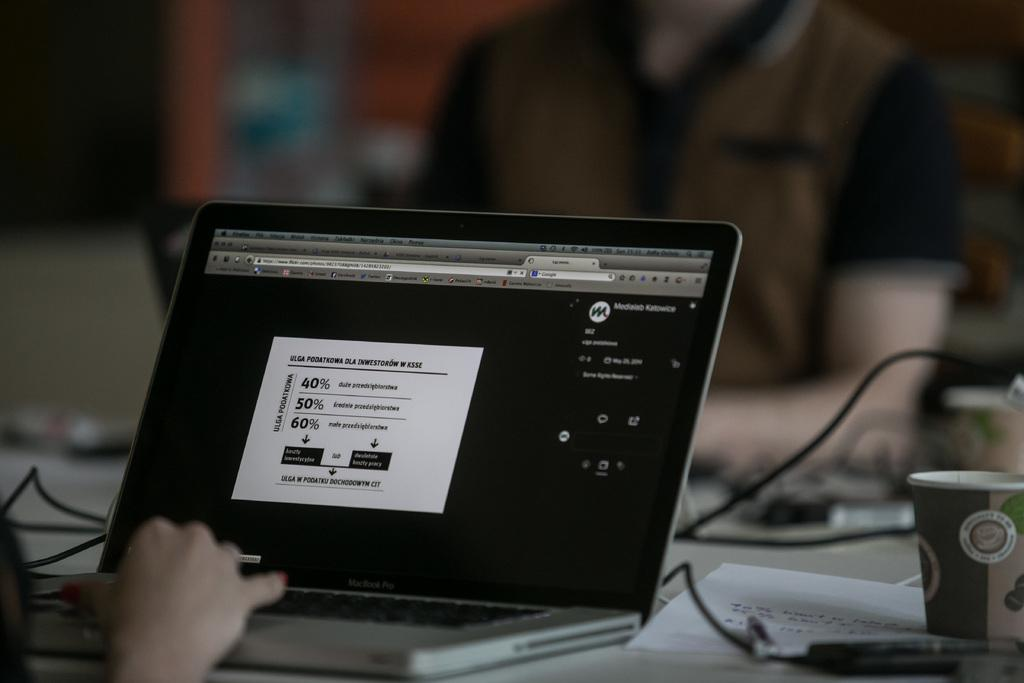How many people are in the image? There are three persons in the image. What electronic device is present in the image? There is a laptop in the image. What else can be seen in the image besides the laptop? There are wires visible in the image, as well as a cup on a table. Can you describe the possible location of the image? The image may have been taken in a hall. What type of gold bun can be seen in the image? There is no gold bun present in the image. What time of day is it in the image? The time of day cannot be determined from the image alone, as there are no specific clues to suggest whether it is morning, afternoon, or evening. 